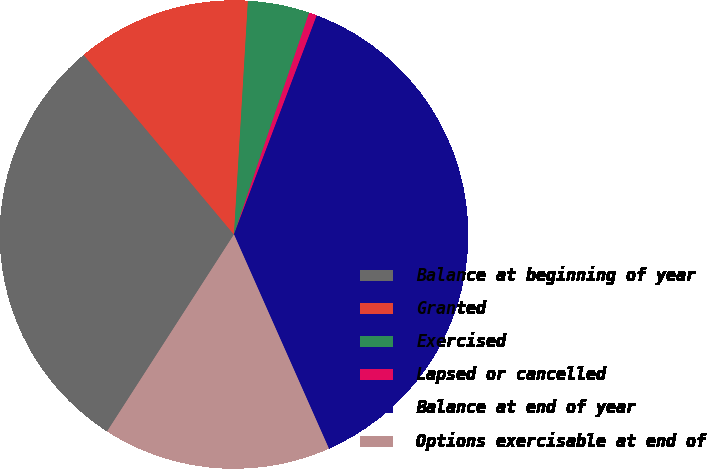Convert chart to OTSL. <chart><loc_0><loc_0><loc_500><loc_500><pie_chart><fcel>Balance at beginning of year<fcel>Granted<fcel>Exercised<fcel>Lapsed or cancelled<fcel>Balance at end of year<fcel>Options exercisable at end of<nl><fcel>29.8%<fcel>12.04%<fcel>4.25%<fcel>0.55%<fcel>37.61%<fcel>15.75%<nl></chart> 